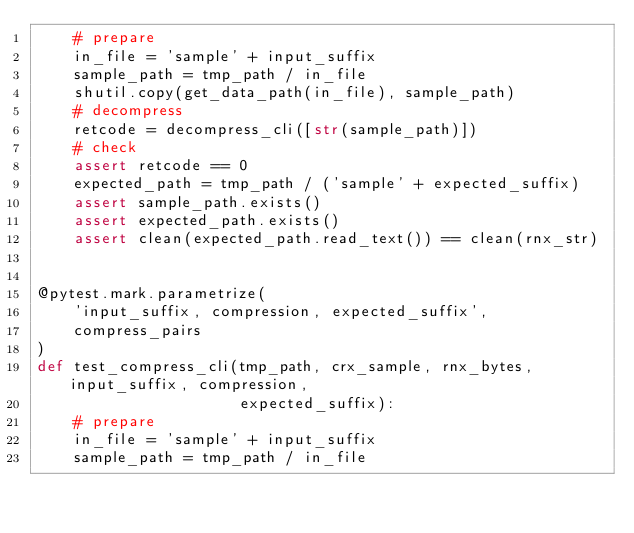<code> <loc_0><loc_0><loc_500><loc_500><_Python_>    # prepare
    in_file = 'sample' + input_suffix
    sample_path = tmp_path / in_file
    shutil.copy(get_data_path(in_file), sample_path)
    # decompress
    retcode = decompress_cli([str(sample_path)])
    # check
    assert retcode == 0
    expected_path = tmp_path / ('sample' + expected_suffix)
    assert sample_path.exists()
    assert expected_path.exists()
    assert clean(expected_path.read_text()) == clean(rnx_str)


@pytest.mark.parametrize(
    'input_suffix, compression, expected_suffix',
    compress_pairs
)
def test_compress_cli(tmp_path, crx_sample, rnx_bytes, input_suffix, compression,
                      expected_suffix):
    # prepare
    in_file = 'sample' + input_suffix
    sample_path = tmp_path / in_file</code> 